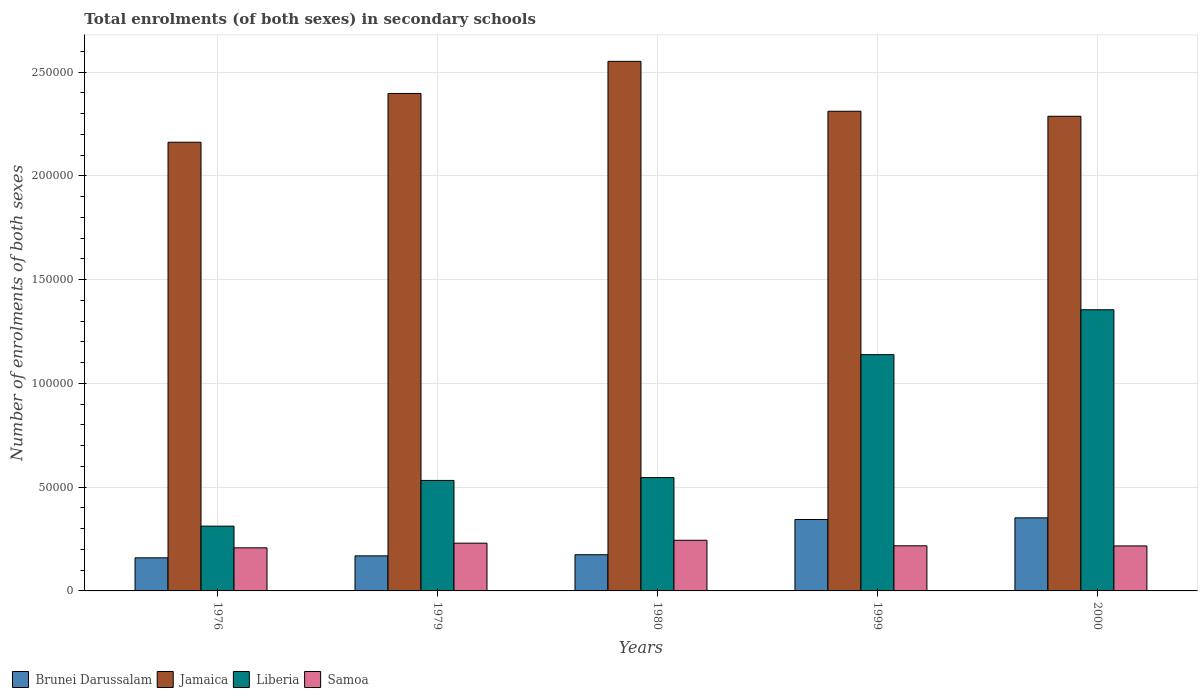How many groups of bars are there?
Ensure brevity in your answer.  5. Are the number of bars per tick equal to the number of legend labels?
Your response must be concise. Yes. Are the number of bars on each tick of the X-axis equal?
Offer a terse response. Yes. How many bars are there on the 2nd tick from the left?
Give a very brief answer. 4. What is the label of the 1st group of bars from the left?
Provide a succinct answer. 1976. In how many cases, is the number of bars for a given year not equal to the number of legend labels?
Provide a succinct answer. 0. What is the number of enrolments in secondary schools in Jamaica in 1976?
Give a very brief answer. 2.16e+05. Across all years, what is the maximum number of enrolments in secondary schools in Liberia?
Provide a succinct answer. 1.36e+05. Across all years, what is the minimum number of enrolments in secondary schools in Brunei Darussalam?
Provide a succinct answer. 1.59e+04. In which year was the number of enrolments in secondary schools in Liberia minimum?
Make the answer very short. 1976. What is the total number of enrolments in secondary schools in Jamaica in the graph?
Ensure brevity in your answer.  1.17e+06. What is the difference between the number of enrolments in secondary schools in Brunei Darussalam in 1979 and that in 2000?
Make the answer very short. -1.83e+04. What is the difference between the number of enrolments in secondary schools in Samoa in 2000 and the number of enrolments in secondary schools in Liberia in 1999?
Make the answer very short. -9.22e+04. What is the average number of enrolments in secondary schools in Samoa per year?
Give a very brief answer. 2.23e+04. In the year 1980, what is the difference between the number of enrolments in secondary schools in Brunei Darussalam and number of enrolments in secondary schools in Jamaica?
Offer a very short reply. -2.38e+05. What is the ratio of the number of enrolments in secondary schools in Jamaica in 1979 to that in 1999?
Give a very brief answer. 1.04. Is the number of enrolments in secondary schools in Jamaica in 1980 less than that in 2000?
Provide a short and direct response. No. Is the difference between the number of enrolments in secondary schools in Brunei Darussalam in 1979 and 1999 greater than the difference between the number of enrolments in secondary schools in Jamaica in 1979 and 1999?
Make the answer very short. No. What is the difference between the highest and the second highest number of enrolments in secondary schools in Jamaica?
Make the answer very short. 1.55e+04. What is the difference between the highest and the lowest number of enrolments in secondary schools in Brunei Darussalam?
Ensure brevity in your answer.  1.93e+04. What does the 1st bar from the left in 1999 represents?
Your answer should be very brief. Brunei Darussalam. What does the 4th bar from the right in 1979 represents?
Your answer should be compact. Brunei Darussalam. Is it the case that in every year, the sum of the number of enrolments in secondary schools in Jamaica and number of enrolments in secondary schools in Samoa is greater than the number of enrolments in secondary schools in Brunei Darussalam?
Offer a very short reply. Yes. How many bars are there?
Your answer should be very brief. 20. Are all the bars in the graph horizontal?
Your answer should be very brief. No. Does the graph contain any zero values?
Your response must be concise. No. Does the graph contain grids?
Provide a short and direct response. Yes. Where does the legend appear in the graph?
Ensure brevity in your answer.  Bottom left. How many legend labels are there?
Keep it short and to the point. 4. What is the title of the graph?
Your answer should be compact. Total enrolments (of both sexes) in secondary schools. Does "Mozambique" appear as one of the legend labels in the graph?
Your answer should be compact. No. What is the label or title of the Y-axis?
Offer a terse response. Number of enrolments of both sexes. What is the Number of enrolments of both sexes of Brunei Darussalam in 1976?
Your response must be concise. 1.59e+04. What is the Number of enrolments of both sexes in Jamaica in 1976?
Your answer should be very brief. 2.16e+05. What is the Number of enrolments of both sexes in Liberia in 1976?
Make the answer very short. 3.12e+04. What is the Number of enrolments of both sexes of Samoa in 1976?
Provide a short and direct response. 2.08e+04. What is the Number of enrolments of both sexes of Brunei Darussalam in 1979?
Your answer should be very brief. 1.69e+04. What is the Number of enrolments of both sexes in Jamaica in 1979?
Provide a short and direct response. 2.40e+05. What is the Number of enrolments of both sexes in Liberia in 1979?
Your answer should be very brief. 5.33e+04. What is the Number of enrolments of both sexes of Samoa in 1979?
Your answer should be very brief. 2.30e+04. What is the Number of enrolments of both sexes in Brunei Darussalam in 1980?
Provide a succinct answer. 1.74e+04. What is the Number of enrolments of both sexes of Jamaica in 1980?
Provide a short and direct response. 2.55e+05. What is the Number of enrolments of both sexes of Liberia in 1980?
Your response must be concise. 5.46e+04. What is the Number of enrolments of both sexes of Samoa in 1980?
Your response must be concise. 2.44e+04. What is the Number of enrolments of both sexes of Brunei Darussalam in 1999?
Offer a terse response. 3.44e+04. What is the Number of enrolments of both sexes in Jamaica in 1999?
Ensure brevity in your answer.  2.31e+05. What is the Number of enrolments of both sexes in Liberia in 1999?
Give a very brief answer. 1.14e+05. What is the Number of enrolments of both sexes in Samoa in 1999?
Give a very brief answer. 2.17e+04. What is the Number of enrolments of both sexes of Brunei Darussalam in 2000?
Your answer should be compact. 3.52e+04. What is the Number of enrolments of both sexes of Jamaica in 2000?
Your answer should be very brief. 2.29e+05. What is the Number of enrolments of both sexes in Liberia in 2000?
Your answer should be very brief. 1.36e+05. What is the Number of enrolments of both sexes of Samoa in 2000?
Provide a succinct answer. 2.17e+04. Across all years, what is the maximum Number of enrolments of both sexes of Brunei Darussalam?
Your answer should be compact. 3.52e+04. Across all years, what is the maximum Number of enrolments of both sexes in Jamaica?
Your answer should be very brief. 2.55e+05. Across all years, what is the maximum Number of enrolments of both sexes in Liberia?
Your answer should be very brief. 1.36e+05. Across all years, what is the maximum Number of enrolments of both sexes in Samoa?
Make the answer very short. 2.44e+04. Across all years, what is the minimum Number of enrolments of both sexes of Brunei Darussalam?
Ensure brevity in your answer.  1.59e+04. Across all years, what is the minimum Number of enrolments of both sexes of Jamaica?
Provide a short and direct response. 2.16e+05. Across all years, what is the minimum Number of enrolments of both sexes of Liberia?
Make the answer very short. 3.12e+04. Across all years, what is the minimum Number of enrolments of both sexes of Samoa?
Give a very brief answer. 2.08e+04. What is the total Number of enrolments of both sexes in Brunei Darussalam in the graph?
Your answer should be very brief. 1.20e+05. What is the total Number of enrolments of both sexes in Jamaica in the graph?
Your answer should be very brief. 1.17e+06. What is the total Number of enrolments of both sexes of Liberia in the graph?
Your answer should be very brief. 3.88e+05. What is the total Number of enrolments of both sexes of Samoa in the graph?
Make the answer very short. 1.12e+05. What is the difference between the Number of enrolments of both sexes of Brunei Darussalam in 1976 and that in 1979?
Provide a succinct answer. -945. What is the difference between the Number of enrolments of both sexes in Jamaica in 1976 and that in 1979?
Give a very brief answer. -2.35e+04. What is the difference between the Number of enrolments of both sexes of Liberia in 1976 and that in 1979?
Provide a succinct answer. -2.20e+04. What is the difference between the Number of enrolments of both sexes in Samoa in 1976 and that in 1979?
Your response must be concise. -2250. What is the difference between the Number of enrolments of both sexes in Brunei Darussalam in 1976 and that in 1980?
Your answer should be compact. -1495. What is the difference between the Number of enrolments of both sexes in Jamaica in 1976 and that in 1980?
Ensure brevity in your answer.  -3.90e+04. What is the difference between the Number of enrolments of both sexes in Liberia in 1976 and that in 1980?
Your answer should be compact. -2.34e+04. What is the difference between the Number of enrolments of both sexes in Samoa in 1976 and that in 1980?
Provide a succinct answer. -3643. What is the difference between the Number of enrolments of both sexes in Brunei Darussalam in 1976 and that in 1999?
Ensure brevity in your answer.  -1.85e+04. What is the difference between the Number of enrolments of both sexes of Jamaica in 1976 and that in 1999?
Your answer should be very brief. -1.49e+04. What is the difference between the Number of enrolments of both sexes in Liberia in 1976 and that in 1999?
Keep it short and to the point. -8.27e+04. What is the difference between the Number of enrolments of both sexes of Samoa in 1976 and that in 1999?
Ensure brevity in your answer.  -982. What is the difference between the Number of enrolments of both sexes in Brunei Darussalam in 1976 and that in 2000?
Ensure brevity in your answer.  -1.93e+04. What is the difference between the Number of enrolments of both sexes of Jamaica in 1976 and that in 2000?
Give a very brief answer. -1.25e+04. What is the difference between the Number of enrolments of both sexes of Liberia in 1976 and that in 2000?
Ensure brevity in your answer.  -1.04e+05. What is the difference between the Number of enrolments of both sexes of Samoa in 1976 and that in 2000?
Your answer should be compact. -915. What is the difference between the Number of enrolments of both sexes of Brunei Darussalam in 1979 and that in 1980?
Your answer should be compact. -550. What is the difference between the Number of enrolments of both sexes in Jamaica in 1979 and that in 1980?
Ensure brevity in your answer.  -1.55e+04. What is the difference between the Number of enrolments of both sexes in Liberia in 1979 and that in 1980?
Give a very brief answer. -1369. What is the difference between the Number of enrolments of both sexes in Samoa in 1979 and that in 1980?
Provide a succinct answer. -1393. What is the difference between the Number of enrolments of both sexes in Brunei Darussalam in 1979 and that in 1999?
Offer a very short reply. -1.75e+04. What is the difference between the Number of enrolments of both sexes of Jamaica in 1979 and that in 1999?
Offer a very short reply. 8582. What is the difference between the Number of enrolments of both sexes in Liberia in 1979 and that in 1999?
Your answer should be compact. -6.06e+04. What is the difference between the Number of enrolments of both sexes of Samoa in 1979 and that in 1999?
Make the answer very short. 1268. What is the difference between the Number of enrolments of both sexes of Brunei Darussalam in 1979 and that in 2000?
Your response must be concise. -1.83e+04. What is the difference between the Number of enrolments of both sexes in Jamaica in 1979 and that in 2000?
Your answer should be very brief. 1.10e+04. What is the difference between the Number of enrolments of both sexes of Liberia in 1979 and that in 2000?
Provide a short and direct response. -8.23e+04. What is the difference between the Number of enrolments of both sexes of Samoa in 1979 and that in 2000?
Make the answer very short. 1335. What is the difference between the Number of enrolments of both sexes of Brunei Darussalam in 1980 and that in 1999?
Your answer should be very brief. -1.70e+04. What is the difference between the Number of enrolments of both sexes of Jamaica in 1980 and that in 1999?
Your answer should be very brief. 2.41e+04. What is the difference between the Number of enrolments of both sexes of Liberia in 1980 and that in 1999?
Keep it short and to the point. -5.93e+04. What is the difference between the Number of enrolments of both sexes in Samoa in 1980 and that in 1999?
Keep it short and to the point. 2661. What is the difference between the Number of enrolments of both sexes of Brunei Darussalam in 1980 and that in 2000?
Keep it short and to the point. -1.78e+04. What is the difference between the Number of enrolments of both sexes in Jamaica in 1980 and that in 2000?
Offer a very short reply. 2.65e+04. What is the difference between the Number of enrolments of both sexes in Liberia in 1980 and that in 2000?
Make the answer very short. -8.09e+04. What is the difference between the Number of enrolments of both sexes in Samoa in 1980 and that in 2000?
Offer a very short reply. 2728. What is the difference between the Number of enrolments of both sexes of Brunei Darussalam in 1999 and that in 2000?
Keep it short and to the point. -783. What is the difference between the Number of enrolments of both sexes of Jamaica in 1999 and that in 2000?
Your answer should be very brief. 2413. What is the difference between the Number of enrolments of both sexes of Liberia in 1999 and that in 2000?
Give a very brief answer. -2.16e+04. What is the difference between the Number of enrolments of both sexes in Samoa in 1999 and that in 2000?
Give a very brief answer. 67. What is the difference between the Number of enrolments of both sexes in Brunei Darussalam in 1976 and the Number of enrolments of both sexes in Jamaica in 1979?
Your response must be concise. -2.24e+05. What is the difference between the Number of enrolments of both sexes in Brunei Darussalam in 1976 and the Number of enrolments of both sexes in Liberia in 1979?
Offer a terse response. -3.73e+04. What is the difference between the Number of enrolments of both sexes of Brunei Darussalam in 1976 and the Number of enrolments of both sexes of Samoa in 1979?
Provide a short and direct response. -7070. What is the difference between the Number of enrolments of both sexes in Jamaica in 1976 and the Number of enrolments of both sexes in Liberia in 1979?
Your answer should be very brief. 1.63e+05. What is the difference between the Number of enrolments of both sexes of Jamaica in 1976 and the Number of enrolments of both sexes of Samoa in 1979?
Make the answer very short. 1.93e+05. What is the difference between the Number of enrolments of both sexes in Liberia in 1976 and the Number of enrolments of both sexes in Samoa in 1979?
Your response must be concise. 8208. What is the difference between the Number of enrolments of both sexes in Brunei Darussalam in 1976 and the Number of enrolments of both sexes in Jamaica in 1980?
Offer a very short reply. -2.39e+05. What is the difference between the Number of enrolments of both sexes in Brunei Darussalam in 1976 and the Number of enrolments of both sexes in Liberia in 1980?
Ensure brevity in your answer.  -3.87e+04. What is the difference between the Number of enrolments of both sexes of Brunei Darussalam in 1976 and the Number of enrolments of both sexes of Samoa in 1980?
Keep it short and to the point. -8463. What is the difference between the Number of enrolments of both sexes of Jamaica in 1976 and the Number of enrolments of both sexes of Liberia in 1980?
Your answer should be very brief. 1.62e+05. What is the difference between the Number of enrolments of both sexes of Jamaica in 1976 and the Number of enrolments of both sexes of Samoa in 1980?
Your answer should be very brief. 1.92e+05. What is the difference between the Number of enrolments of both sexes of Liberia in 1976 and the Number of enrolments of both sexes of Samoa in 1980?
Keep it short and to the point. 6815. What is the difference between the Number of enrolments of both sexes in Brunei Darussalam in 1976 and the Number of enrolments of both sexes in Jamaica in 1999?
Ensure brevity in your answer.  -2.15e+05. What is the difference between the Number of enrolments of both sexes of Brunei Darussalam in 1976 and the Number of enrolments of both sexes of Liberia in 1999?
Offer a very short reply. -9.79e+04. What is the difference between the Number of enrolments of both sexes in Brunei Darussalam in 1976 and the Number of enrolments of both sexes in Samoa in 1999?
Offer a terse response. -5802. What is the difference between the Number of enrolments of both sexes in Jamaica in 1976 and the Number of enrolments of both sexes in Liberia in 1999?
Provide a succinct answer. 1.02e+05. What is the difference between the Number of enrolments of both sexes of Jamaica in 1976 and the Number of enrolments of both sexes of Samoa in 1999?
Offer a terse response. 1.94e+05. What is the difference between the Number of enrolments of both sexes of Liberia in 1976 and the Number of enrolments of both sexes of Samoa in 1999?
Offer a very short reply. 9476. What is the difference between the Number of enrolments of both sexes of Brunei Darussalam in 1976 and the Number of enrolments of both sexes of Jamaica in 2000?
Your response must be concise. -2.13e+05. What is the difference between the Number of enrolments of both sexes in Brunei Darussalam in 1976 and the Number of enrolments of both sexes in Liberia in 2000?
Your answer should be very brief. -1.20e+05. What is the difference between the Number of enrolments of both sexes of Brunei Darussalam in 1976 and the Number of enrolments of both sexes of Samoa in 2000?
Offer a very short reply. -5735. What is the difference between the Number of enrolments of both sexes in Jamaica in 1976 and the Number of enrolments of both sexes in Liberia in 2000?
Give a very brief answer. 8.07e+04. What is the difference between the Number of enrolments of both sexes of Jamaica in 1976 and the Number of enrolments of both sexes of Samoa in 2000?
Give a very brief answer. 1.95e+05. What is the difference between the Number of enrolments of both sexes of Liberia in 1976 and the Number of enrolments of both sexes of Samoa in 2000?
Provide a succinct answer. 9543. What is the difference between the Number of enrolments of both sexes of Brunei Darussalam in 1979 and the Number of enrolments of both sexes of Jamaica in 1980?
Provide a succinct answer. -2.38e+05. What is the difference between the Number of enrolments of both sexes of Brunei Darussalam in 1979 and the Number of enrolments of both sexes of Liberia in 1980?
Your response must be concise. -3.77e+04. What is the difference between the Number of enrolments of both sexes of Brunei Darussalam in 1979 and the Number of enrolments of both sexes of Samoa in 1980?
Your answer should be very brief. -7518. What is the difference between the Number of enrolments of both sexes of Jamaica in 1979 and the Number of enrolments of both sexes of Liberia in 1980?
Keep it short and to the point. 1.85e+05. What is the difference between the Number of enrolments of both sexes of Jamaica in 1979 and the Number of enrolments of both sexes of Samoa in 1980?
Your answer should be compact. 2.15e+05. What is the difference between the Number of enrolments of both sexes in Liberia in 1979 and the Number of enrolments of both sexes in Samoa in 1980?
Provide a succinct answer. 2.88e+04. What is the difference between the Number of enrolments of both sexes in Brunei Darussalam in 1979 and the Number of enrolments of both sexes in Jamaica in 1999?
Your answer should be very brief. -2.14e+05. What is the difference between the Number of enrolments of both sexes of Brunei Darussalam in 1979 and the Number of enrolments of both sexes of Liberia in 1999?
Offer a terse response. -9.70e+04. What is the difference between the Number of enrolments of both sexes of Brunei Darussalam in 1979 and the Number of enrolments of both sexes of Samoa in 1999?
Your answer should be very brief. -4857. What is the difference between the Number of enrolments of both sexes in Jamaica in 1979 and the Number of enrolments of both sexes in Liberia in 1999?
Your answer should be compact. 1.26e+05. What is the difference between the Number of enrolments of both sexes in Jamaica in 1979 and the Number of enrolments of both sexes in Samoa in 1999?
Offer a very short reply. 2.18e+05. What is the difference between the Number of enrolments of both sexes of Liberia in 1979 and the Number of enrolments of both sexes of Samoa in 1999?
Provide a short and direct response. 3.15e+04. What is the difference between the Number of enrolments of both sexes of Brunei Darussalam in 1979 and the Number of enrolments of both sexes of Jamaica in 2000?
Your response must be concise. -2.12e+05. What is the difference between the Number of enrolments of both sexes in Brunei Darussalam in 1979 and the Number of enrolments of both sexes in Liberia in 2000?
Your response must be concise. -1.19e+05. What is the difference between the Number of enrolments of both sexes in Brunei Darussalam in 1979 and the Number of enrolments of both sexes in Samoa in 2000?
Your response must be concise. -4790. What is the difference between the Number of enrolments of both sexes in Jamaica in 1979 and the Number of enrolments of both sexes in Liberia in 2000?
Keep it short and to the point. 1.04e+05. What is the difference between the Number of enrolments of both sexes in Jamaica in 1979 and the Number of enrolments of both sexes in Samoa in 2000?
Offer a very short reply. 2.18e+05. What is the difference between the Number of enrolments of both sexes in Liberia in 1979 and the Number of enrolments of both sexes in Samoa in 2000?
Offer a very short reply. 3.16e+04. What is the difference between the Number of enrolments of both sexes of Brunei Darussalam in 1980 and the Number of enrolments of both sexes of Jamaica in 1999?
Give a very brief answer. -2.14e+05. What is the difference between the Number of enrolments of both sexes of Brunei Darussalam in 1980 and the Number of enrolments of both sexes of Liberia in 1999?
Keep it short and to the point. -9.64e+04. What is the difference between the Number of enrolments of both sexes in Brunei Darussalam in 1980 and the Number of enrolments of both sexes in Samoa in 1999?
Offer a terse response. -4307. What is the difference between the Number of enrolments of both sexes in Jamaica in 1980 and the Number of enrolments of both sexes in Liberia in 1999?
Offer a very short reply. 1.41e+05. What is the difference between the Number of enrolments of both sexes in Jamaica in 1980 and the Number of enrolments of both sexes in Samoa in 1999?
Ensure brevity in your answer.  2.33e+05. What is the difference between the Number of enrolments of both sexes in Liberia in 1980 and the Number of enrolments of both sexes in Samoa in 1999?
Your response must be concise. 3.29e+04. What is the difference between the Number of enrolments of both sexes in Brunei Darussalam in 1980 and the Number of enrolments of both sexes in Jamaica in 2000?
Provide a succinct answer. -2.11e+05. What is the difference between the Number of enrolments of both sexes of Brunei Darussalam in 1980 and the Number of enrolments of both sexes of Liberia in 2000?
Provide a short and direct response. -1.18e+05. What is the difference between the Number of enrolments of both sexes of Brunei Darussalam in 1980 and the Number of enrolments of both sexes of Samoa in 2000?
Make the answer very short. -4240. What is the difference between the Number of enrolments of both sexes in Jamaica in 1980 and the Number of enrolments of both sexes in Liberia in 2000?
Ensure brevity in your answer.  1.20e+05. What is the difference between the Number of enrolments of both sexes of Jamaica in 1980 and the Number of enrolments of both sexes of Samoa in 2000?
Your response must be concise. 2.34e+05. What is the difference between the Number of enrolments of both sexes in Liberia in 1980 and the Number of enrolments of both sexes in Samoa in 2000?
Your response must be concise. 3.29e+04. What is the difference between the Number of enrolments of both sexes of Brunei Darussalam in 1999 and the Number of enrolments of both sexes of Jamaica in 2000?
Ensure brevity in your answer.  -1.94e+05. What is the difference between the Number of enrolments of both sexes of Brunei Darussalam in 1999 and the Number of enrolments of both sexes of Liberia in 2000?
Ensure brevity in your answer.  -1.01e+05. What is the difference between the Number of enrolments of both sexes of Brunei Darussalam in 1999 and the Number of enrolments of both sexes of Samoa in 2000?
Provide a succinct answer. 1.27e+04. What is the difference between the Number of enrolments of both sexes of Jamaica in 1999 and the Number of enrolments of both sexes of Liberia in 2000?
Make the answer very short. 9.57e+04. What is the difference between the Number of enrolments of both sexes of Jamaica in 1999 and the Number of enrolments of both sexes of Samoa in 2000?
Provide a short and direct response. 2.09e+05. What is the difference between the Number of enrolments of both sexes in Liberia in 1999 and the Number of enrolments of both sexes in Samoa in 2000?
Your response must be concise. 9.22e+04. What is the average Number of enrolments of both sexes in Brunei Darussalam per year?
Make the answer very short. 2.40e+04. What is the average Number of enrolments of both sexes in Jamaica per year?
Provide a short and direct response. 2.34e+05. What is the average Number of enrolments of both sexes of Liberia per year?
Ensure brevity in your answer.  7.77e+04. What is the average Number of enrolments of both sexes in Samoa per year?
Provide a succinct answer. 2.23e+04. In the year 1976, what is the difference between the Number of enrolments of both sexes in Brunei Darussalam and Number of enrolments of both sexes in Jamaica?
Make the answer very short. -2.00e+05. In the year 1976, what is the difference between the Number of enrolments of both sexes of Brunei Darussalam and Number of enrolments of both sexes of Liberia?
Your answer should be very brief. -1.53e+04. In the year 1976, what is the difference between the Number of enrolments of both sexes in Brunei Darussalam and Number of enrolments of both sexes in Samoa?
Provide a succinct answer. -4820. In the year 1976, what is the difference between the Number of enrolments of both sexes of Jamaica and Number of enrolments of both sexes of Liberia?
Your answer should be very brief. 1.85e+05. In the year 1976, what is the difference between the Number of enrolments of both sexes of Jamaica and Number of enrolments of both sexes of Samoa?
Your answer should be very brief. 1.95e+05. In the year 1976, what is the difference between the Number of enrolments of both sexes in Liberia and Number of enrolments of both sexes in Samoa?
Provide a short and direct response. 1.05e+04. In the year 1979, what is the difference between the Number of enrolments of both sexes in Brunei Darussalam and Number of enrolments of both sexes in Jamaica?
Provide a succinct answer. -2.23e+05. In the year 1979, what is the difference between the Number of enrolments of both sexes in Brunei Darussalam and Number of enrolments of both sexes in Liberia?
Offer a terse response. -3.64e+04. In the year 1979, what is the difference between the Number of enrolments of both sexes in Brunei Darussalam and Number of enrolments of both sexes in Samoa?
Keep it short and to the point. -6125. In the year 1979, what is the difference between the Number of enrolments of both sexes in Jamaica and Number of enrolments of both sexes in Liberia?
Keep it short and to the point. 1.87e+05. In the year 1979, what is the difference between the Number of enrolments of both sexes of Jamaica and Number of enrolments of both sexes of Samoa?
Offer a terse response. 2.17e+05. In the year 1979, what is the difference between the Number of enrolments of both sexes of Liberia and Number of enrolments of both sexes of Samoa?
Provide a succinct answer. 3.02e+04. In the year 1980, what is the difference between the Number of enrolments of both sexes in Brunei Darussalam and Number of enrolments of both sexes in Jamaica?
Ensure brevity in your answer.  -2.38e+05. In the year 1980, what is the difference between the Number of enrolments of both sexes in Brunei Darussalam and Number of enrolments of both sexes in Liberia?
Make the answer very short. -3.72e+04. In the year 1980, what is the difference between the Number of enrolments of both sexes in Brunei Darussalam and Number of enrolments of both sexes in Samoa?
Give a very brief answer. -6968. In the year 1980, what is the difference between the Number of enrolments of both sexes in Jamaica and Number of enrolments of both sexes in Liberia?
Give a very brief answer. 2.01e+05. In the year 1980, what is the difference between the Number of enrolments of both sexes of Jamaica and Number of enrolments of both sexes of Samoa?
Your answer should be very brief. 2.31e+05. In the year 1980, what is the difference between the Number of enrolments of both sexes in Liberia and Number of enrolments of both sexes in Samoa?
Provide a short and direct response. 3.02e+04. In the year 1999, what is the difference between the Number of enrolments of both sexes in Brunei Darussalam and Number of enrolments of both sexes in Jamaica?
Ensure brevity in your answer.  -1.97e+05. In the year 1999, what is the difference between the Number of enrolments of both sexes of Brunei Darussalam and Number of enrolments of both sexes of Liberia?
Your answer should be very brief. -7.95e+04. In the year 1999, what is the difference between the Number of enrolments of both sexes of Brunei Darussalam and Number of enrolments of both sexes of Samoa?
Offer a terse response. 1.27e+04. In the year 1999, what is the difference between the Number of enrolments of both sexes of Jamaica and Number of enrolments of both sexes of Liberia?
Provide a succinct answer. 1.17e+05. In the year 1999, what is the difference between the Number of enrolments of both sexes in Jamaica and Number of enrolments of both sexes in Samoa?
Make the answer very short. 2.09e+05. In the year 1999, what is the difference between the Number of enrolments of both sexes of Liberia and Number of enrolments of both sexes of Samoa?
Provide a succinct answer. 9.21e+04. In the year 2000, what is the difference between the Number of enrolments of both sexes in Brunei Darussalam and Number of enrolments of both sexes in Jamaica?
Give a very brief answer. -1.94e+05. In the year 2000, what is the difference between the Number of enrolments of both sexes in Brunei Darussalam and Number of enrolments of both sexes in Liberia?
Keep it short and to the point. -1.00e+05. In the year 2000, what is the difference between the Number of enrolments of both sexes in Brunei Darussalam and Number of enrolments of both sexes in Samoa?
Provide a succinct answer. 1.35e+04. In the year 2000, what is the difference between the Number of enrolments of both sexes in Jamaica and Number of enrolments of both sexes in Liberia?
Offer a very short reply. 9.33e+04. In the year 2000, what is the difference between the Number of enrolments of both sexes in Jamaica and Number of enrolments of both sexes in Samoa?
Ensure brevity in your answer.  2.07e+05. In the year 2000, what is the difference between the Number of enrolments of both sexes of Liberia and Number of enrolments of both sexes of Samoa?
Your answer should be compact. 1.14e+05. What is the ratio of the Number of enrolments of both sexes in Brunei Darussalam in 1976 to that in 1979?
Give a very brief answer. 0.94. What is the ratio of the Number of enrolments of both sexes of Jamaica in 1976 to that in 1979?
Ensure brevity in your answer.  0.9. What is the ratio of the Number of enrolments of both sexes in Liberia in 1976 to that in 1979?
Ensure brevity in your answer.  0.59. What is the ratio of the Number of enrolments of both sexes of Samoa in 1976 to that in 1979?
Provide a succinct answer. 0.9. What is the ratio of the Number of enrolments of both sexes of Brunei Darussalam in 1976 to that in 1980?
Offer a very short reply. 0.91. What is the ratio of the Number of enrolments of both sexes in Jamaica in 1976 to that in 1980?
Offer a very short reply. 0.85. What is the ratio of the Number of enrolments of both sexes in Liberia in 1976 to that in 1980?
Offer a very short reply. 0.57. What is the ratio of the Number of enrolments of both sexes in Samoa in 1976 to that in 1980?
Make the answer very short. 0.85. What is the ratio of the Number of enrolments of both sexes in Brunei Darussalam in 1976 to that in 1999?
Keep it short and to the point. 0.46. What is the ratio of the Number of enrolments of both sexes of Jamaica in 1976 to that in 1999?
Your answer should be very brief. 0.94. What is the ratio of the Number of enrolments of both sexes in Liberia in 1976 to that in 1999?
Keep it short and to the point. 0.27. What is the ratio of the Number of enrolments of both sexes of Samoa in 1976 to that in 1999?
Ensure brevity in your answer.  0.95. What is the ratio of the Number of enrolments of both sexes of Brunei Darussalam in 1976 to that in 2000?
Offer a very short reply. 0.45. What is the ratio of the Number of enrolments of both sexes in Jamaica in 1976 to that in 2000?
Ensure brevity in your answer.  0.95. What is the ratio of the Number of enrolments of both sexes of Liberia in 1976 to that in 2000?
Keep it short and to the point. 0.23. What is the ratio of the Number of enrolments of both sexes in Samoa in 1976 to that in 2000?
Ensure brevity in your answer.  0.96. What is the ratio of the Number of enrolments of both sexes in Brunei Darussalam in 1979 to that in 1980?
Your response must be concise. 0.97. What is the ratio of the Number of enrolments of both sexes of Jamaica in 1979 to that in 1980?
Offer a very short reply. 0.94. What is the ratio of the Number of enrolments of both sexes in Liberia in 1979 to that in 1980?
Make the answer very short. 0.97. What is the ratio of the Number of enrolments of both sexes of Samoa in 1979 to that in 1980?
Provide a short and direct response. 0.94. What is the ratio of the Number of enrolments of both sexes in Brunei Darussalam in 1979 to that in 1999?
Provide a succinct answer. 0.49. What is the ratio of the Number of enrolments of both sexes in Jamaica in 1979 to that in 1999?
Ensure brevity in your answer.  1.04. What is the ratio of the Number of enrolments of both sexes of Liberia in 1979 to that in 1999?
Give a very brief answer. 0.47. What is the ratio of the Number of enrolments of both sexes of Samoa in 1979 to that in 1999?
Make the answer very short. 1.06. What is the ratio of the Number of enrolments of both sexes in Brunei Darussalam in 1979 to that in 2000?
Provide a succinct answer. 0.48. What is the ratio of the Number of enrolments of both sexes of Jamaica in 1979 to that in 2000?
Give a very brief answer. 1.05. What is the ratio of the Number of enrolments of both sexes in Liberia in 1979 to that in 2000?
Offer a terse response. 0.39. What is the ratio of the Number of enrolments of both sexes of Samoa in 1979 to that in 2000?
Provide a succinct answer. 1.06. What is the ratio of the Number of enrolments of both sexes in Brunei Darussalam in 1980 to that in 1999?
Your answer should be very brief. 0.51. What is the ratio of the Number of enrolments of both sexes of Jamaica in 1980 to that in 1999?
Make the answer very short. 1.1. What is the ratio of the Number of enrolments of both sexes of Liberia in 1980 to that in 1999?
Provide a succinct answer. 0.48. What is the ratio of the Number of enrolments of both sexes of Samoa in 1980 to that in 1999?
Make the answer very short. 1.12. What is the ratio of the Number of enrolments of both sexes in Brunei Darussalam in 1980 to that in 2000?
Ensure brevity in your answer.  0.5. What is the ratio of the Number of enrolments of both sexes in Jamaica in 1980 to that in 2000?
Offer a very short reply. 1.12. What is the ratio of the Number of enrolments of both sexes in Liberia in 1980 to that in 2000?
Provide a succinct answer. 0.4. What is the ratio of the Number of enrolments of both sexes in Samoa in 1980 to that in 2000?
Keep it short and to the point. 1.13. What is the ratio of the Number of enrolments of both sexes of Brunei Darussalam in 1999 to that in 2000?
Give a very brief answer. 0.98. What is the ratio of the Number of enrolments of both sexes of Jamaica in 1999 to that in 2000?
Offer a very short reply. 1.01. What is the ratio of the Number of enrolments of both sexes of Liberia in 1999 to that in 2000?
Offer a terse response. 0.84. What is the difference between the highest and the second highest Number of enrolments of both sexes of Brunei Darussalam?
Offer a very short reply. 783. What is the difference between the highest and the second highest Number of enrolments of both sexes in Jamaica?
Offer a very short reply. 1.55e+04. What is the difference between the highest and the second highest Number of enrolments of both sexes of Liberia?
Your response must be concise. 2.16e+04. What is the difference between the highest and the second highest Number of enrolments of both sexes in Samoa?
Provide a succinct answer. 1393. What is the difference between the highest and the lowest Number of enrolments of both sexes in Brunei Darussalam?
Offer a terse response. 1.93e+04. What is the difference between the highest and the lowest Number of enrolments of both sexes of Jamaica?
Give a very brief answer. 3.90e+04. What is the difference between the highest and the lowest Number of enrolments of both sexes in Liberia?
Your answer should be very brief. 1.04e+05. What is the difference between the highest and the lowest Number of enrolments of both sexes of Samoa?
Ensure brevity in your answer.  3643. 